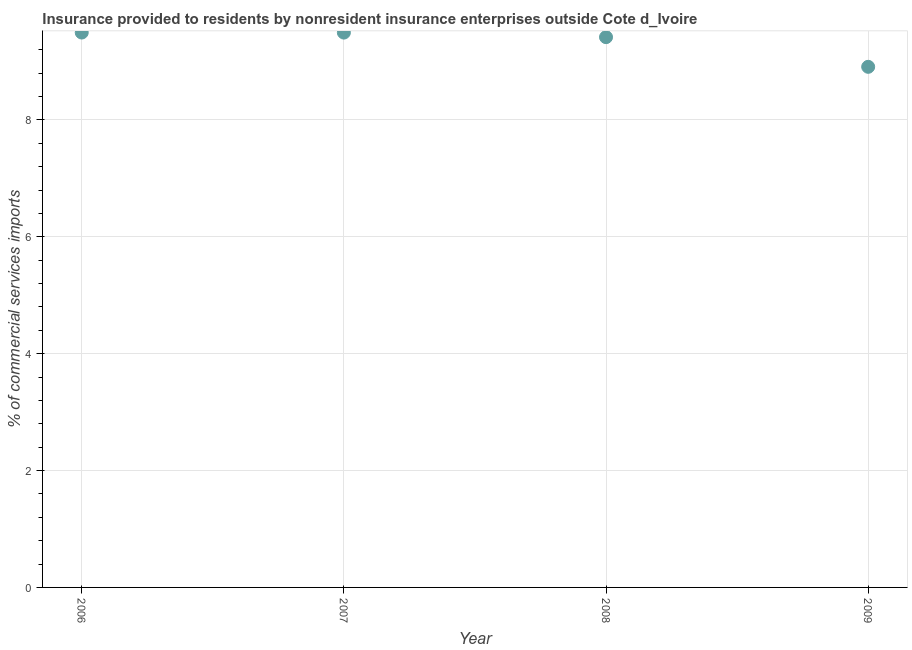What is the insurance provided by non-residents in 2006?
Your response must be concise. 9.5. Across all years, what is the maximum insurance provided by non-residents?
Provide a succinct answer. 9.5. Across all years, what is the minimum insurance provided by non-residents?
Your answer should be very brief. 8.91. In which year was the insurance provided by non-residents maximum?
Make the answer very short. 2006. In which year was the insurance provided by non-residents minimum?
Make the answer very short. 2009. What is the sum of the insurance provided by non-residents?
Provide a short and direct response. 37.32. What is the difference between the insurance provided by non-residents in 2006 and 2008?
Provide a succinct answer. 0.08. What is the average insurance provided by non-residents per year?
Ensure brevity in your answer.  9.33. What is the median insurance provided by non-residents?
Provide a short and direct response. 9.46. Do a majority of the years between 2009 and 2007 (inclusive) have insurance provided by non-residents greater than 5.2 %?
Your answer should be compact. No. What is the ratio of the insurance provided by non-residents in 2006 to that in 2008?
Offer a terse response. 1.01. Is the insurance provided by non-residents in 2006 less than that in 2009?
Your response must be concise. No. Is the difference between the insurance provided by non-residents in 2006 and 2007 greater than the difference between any two years?
Offer a very short reply. No. What is the difference between the highest and the second highest insurance provided by non-residents?
Make the answer very short. 0. What is the difference between the highest and the lowest insurance provided by non-residents?
Make the answer very short. 0.59. In how many years, is the insurance provided by non-residents greater than the average insurance provided by non-residents taken over all years?
Ensure brevity in your answer.  3. Does the insurance provided by non-residents monotonically increase over the years?
Your answer should be compact. No. How many dotlines are there?
Provide a succinct answer. 1. What is the difference between two consecutive major ticks on the Y-axis?
Your answer should be compact. 2. Are the values on the major ticks of Y-axis written in scientific E-notation?
Your answer should be compact. No. Does the graph contain any zero values?
Provide a short and direct response. No. What is the title of the graph?
Offer a very short reply. Insurance provided to residents by nonresident insurance enterprises outside Cote d_Ivoire. What is the label or title of the X-axis?
Give a very brief answer. Year. What is the label or title of the Y-axis?
Provide a succinct answer. % of commercial services imports. What is the % of commercial services imports in 2006?
Your response must be concise. 9.5. What is the % of commercial services imports in 2007?
Ensure brevity in your answer.  9.5. What is the % of commercial services imports in 2008?
Provide a short and direct response. 9.42. What is the % of commercial services imports in 2009?
Offer a terse response. 8.91. What is the difference between the % of commercial services imports in 2006 and 2007?
Give a very brief answer. 0. What is the difference between the % of commercial services imports in 2006 and 2008?
Keep it short and to the point. 0.08. What is the difference between the % of commercial services imports in 2006 and 2009?
Your response must be concise. 0.59. What is the difference between the % of commercial services imports in 2007 and 2008?
Keep it short and to the point. 0.08. What is the difference between the % of commercial services imports in 2007 and 2009?
Give a very brief answer. 0.59. What is the difference between the % of commercial services imports in 2008 and 2009?
Ensure brevity in your answer.  0.51. What is the ratio of the % of commercial services imports in 2006 to that in 2007?
Ensure brevity in your answer.  1. What is the ratio of the % of commercial services imports in 2006 to that in 2009?
Offer a terse response. 1.07. What is the ratio of the % of commercial services imports in 2007 to that in 2009?
Provide a short and direct response. 1.07. What is the ratio of the % of commercial services imports in 2008 to that in 2009?
Your answer should be compact. 1.06. 